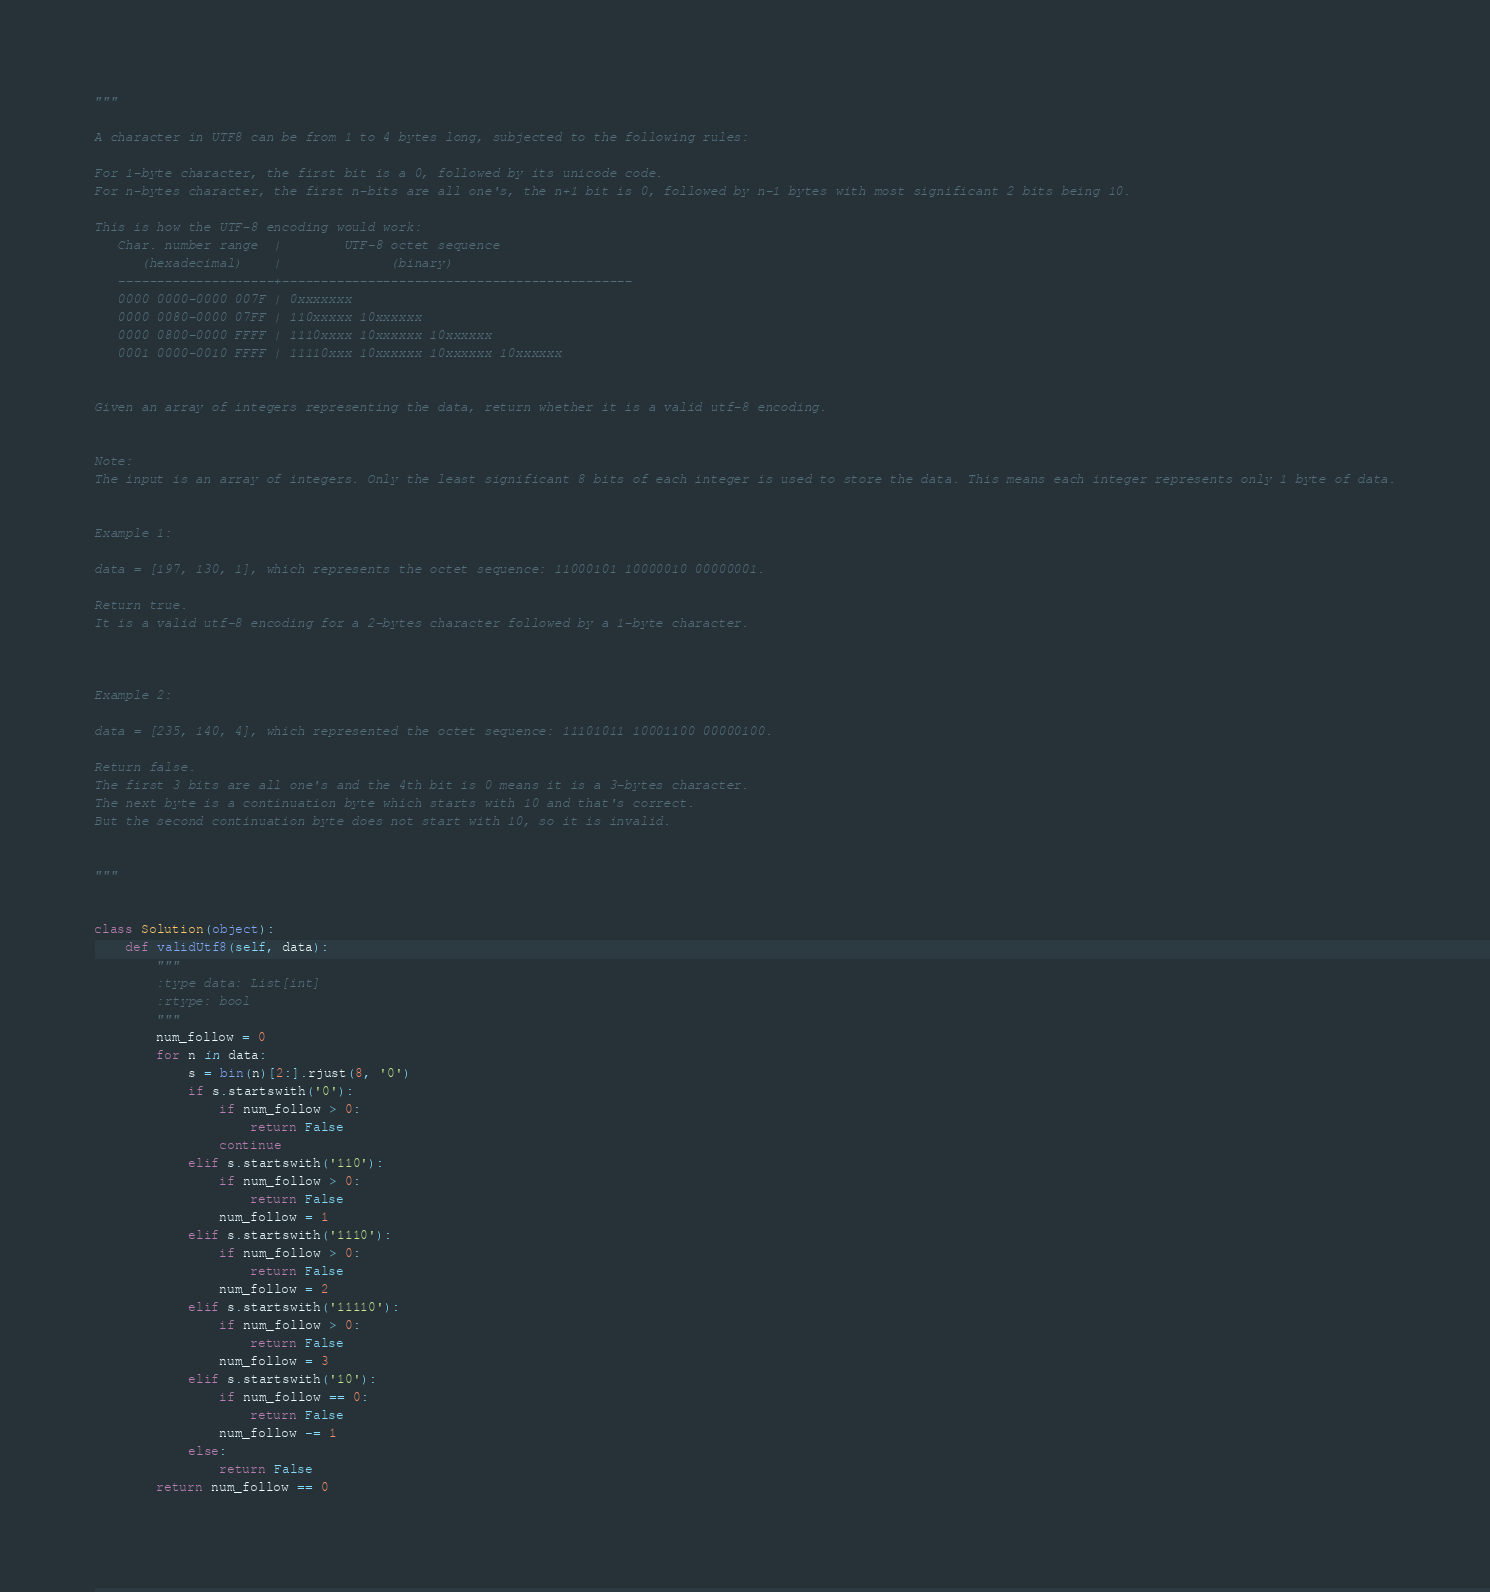<code> <loc_0><loc_0><loc_500><loc_500><_Python_>"""

A character in UTF8 can be from 1 to 4 bytes long, subjected to the following rules:

For 1-byte character, the first bit is a 0, followed by its unicode code.
For n-bytes character, the first n-bits are all one's, the n+1 bit is 0, followed by n-1 bytes with most significant 2 bits being 10.

This is how the UTF-8 encoding would work:
   Char. number range  |        UTF-8 octet sequence
      (hexadecimal)    |              (binary)
   --------------------+---------------------------------------------
   0000 0000-0000 007F | 0xxxxxxx
   0000 0080-0000 07FF | 110xxxxx 10xxxxxx
   0000 0800-0000 FFFF | 1110xxxx 10xxxxxx 10xxxxxx
   0001 0000-0010 FFFF | 11110xxx 10xxxxxx 10xxxxxx 10xxxxxx


Given an array of integers representing the data, return whether it is a valid utf-8 encoding.


Note:
The input is an array of integers. Only the least significant 8 bits of each integer is used to store the data. This means each integer represents only 1 byte of data.


Example 1:

data = [197, 130, 1], which represents the octet sequence: 11000101 10000010 00000001.

Return true.
It is a valid utf-8 encoding for a 2-bytes character followed by a 1-byte character.



Example 2:

data = [235, 140, 4], which represented the octet sequence: 11101011 10001100 00000100.

Return false.
The first 3 bits are all one's and the 4th bit is 0 means it is a 3-bytes character.
The next byte is a continuation byte which starts with 10 and that's correct.
But the second continuation byte does not start with 10, so it is invalid.


"""


class Solution(object):
    def validUtf8(self, data):
        """
        :type data: List[int]
        :rtype: bool
        """
        num_follow = 0
        for n in data:
            s = bin(n)[2:].rjust(8, '0')
            if s.startswith('0'):
                if num_follow > 0:
                    return False
                continue
            elif s.startswith('110'):
                if num_follow > 0:
                    return False
                num_follow = 1
            elif s.startswith('1110'):
                if num_follow > 0:
                    return False
                num_follow = 2
            elif s.startswith('11110'):
                if num_follow > 0:
                    return False
                num_follow = 3
            elif s.startswith('10'):
                if num_follow == 0:
                    return False
                num_follow -= 1
            else:
                return False
        return num_follow == 0</code> 